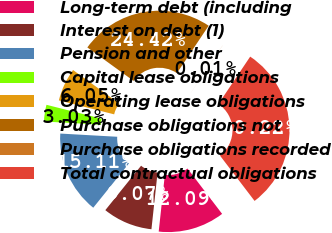<chart> <loc_0><loc_0><loc_500><loc_500><pie_chart><fcel>Long-term debt (including<fcel>Interest on debt (1)<fcel>Pension and other<fcel>Capital lease obligations<fcel>Operating lease obligations<fcel>Purchase obligations not<fcel>Purchase obligations recorded<fcel>Total contractual obligations<nl><fcel>12.09%<fcel>9.07%<fcel>15.11%<fcel>3.03%<fcel>6.05%<fcel>24.42%<fcel>0.01%<fcel>30.22%<nl></chart> 